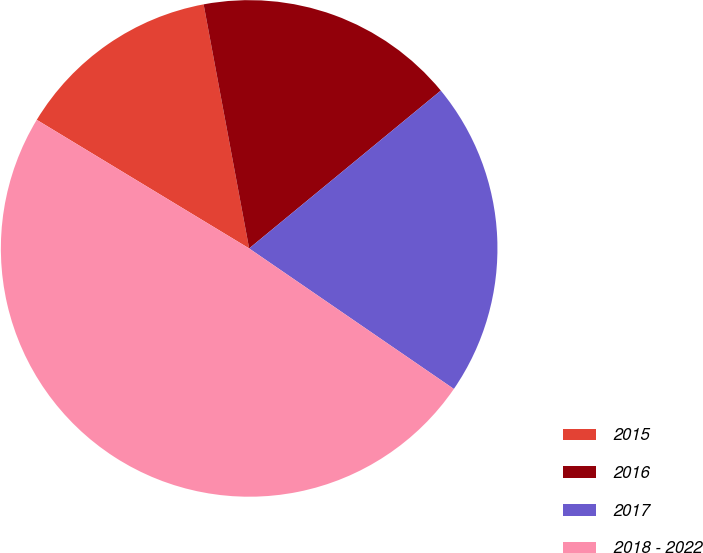Convert chart. <chart><loc_0><loc_0><loc_500><loc_500><pie_chart><fcel>2015<fcel>2016<fcel>2017<fcel>2018 - 2022<nl><fcel>13.4%<fcel>16.97%<fcel>20.54%<fcel>49.09%<nl></chart> 